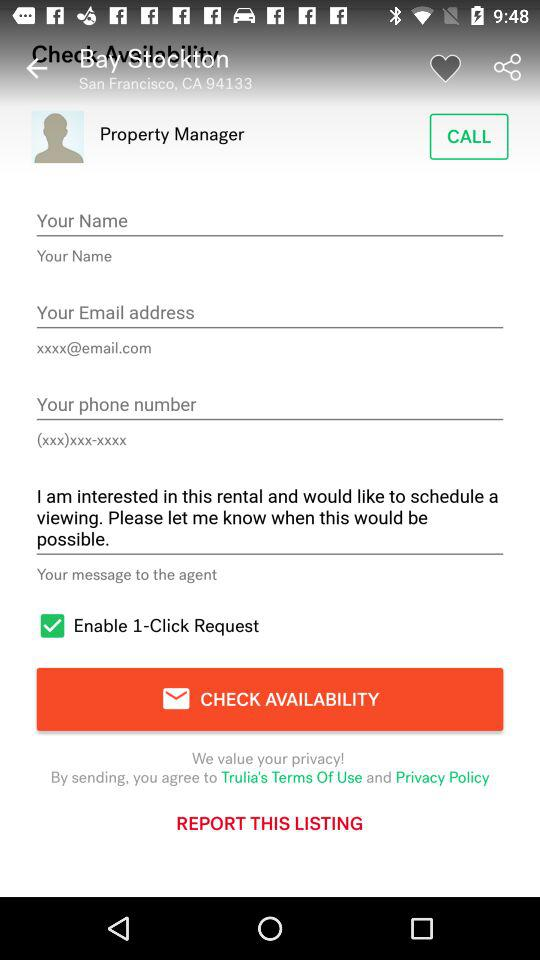What is the designation? The designation is "Property Manager". 